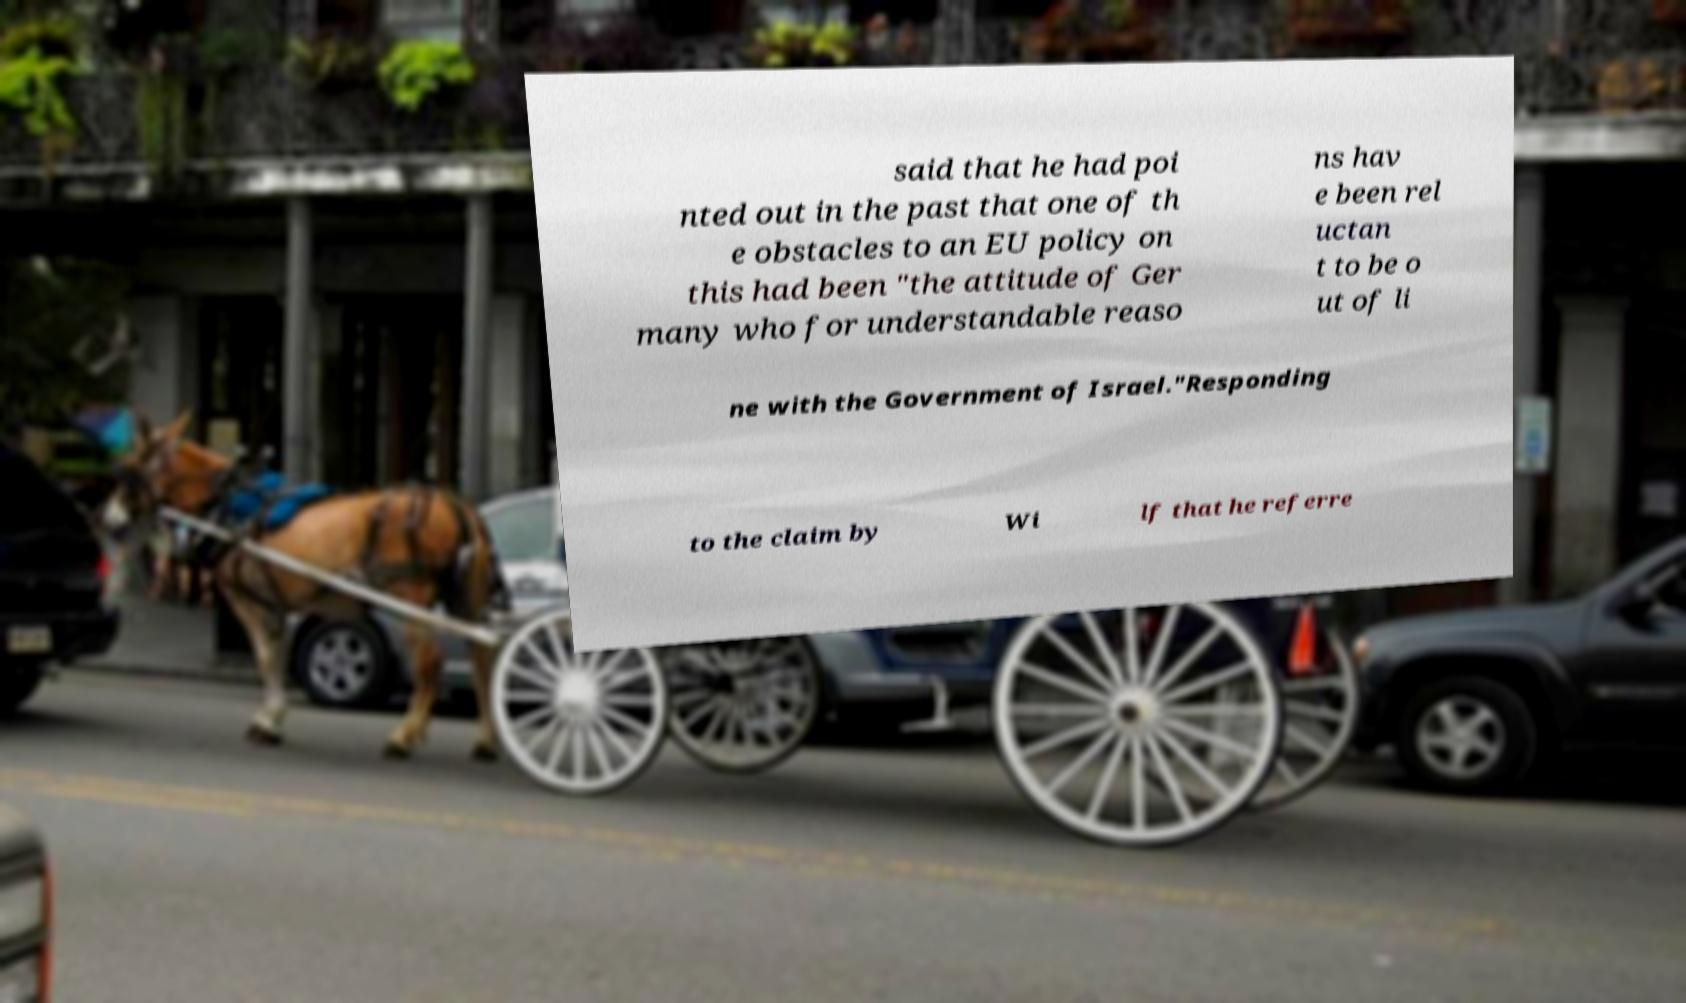Please identify and transcribe the text found in this image. said that he had poi nted out in the past that one of th e obstacles to an EU policy on this had been "the attitude of Ger many who for understandable reaso ns hav e been rel uctan t to be o ut of li ne with the Government of Israel."Responding to the claim by Wi lf that he referre 